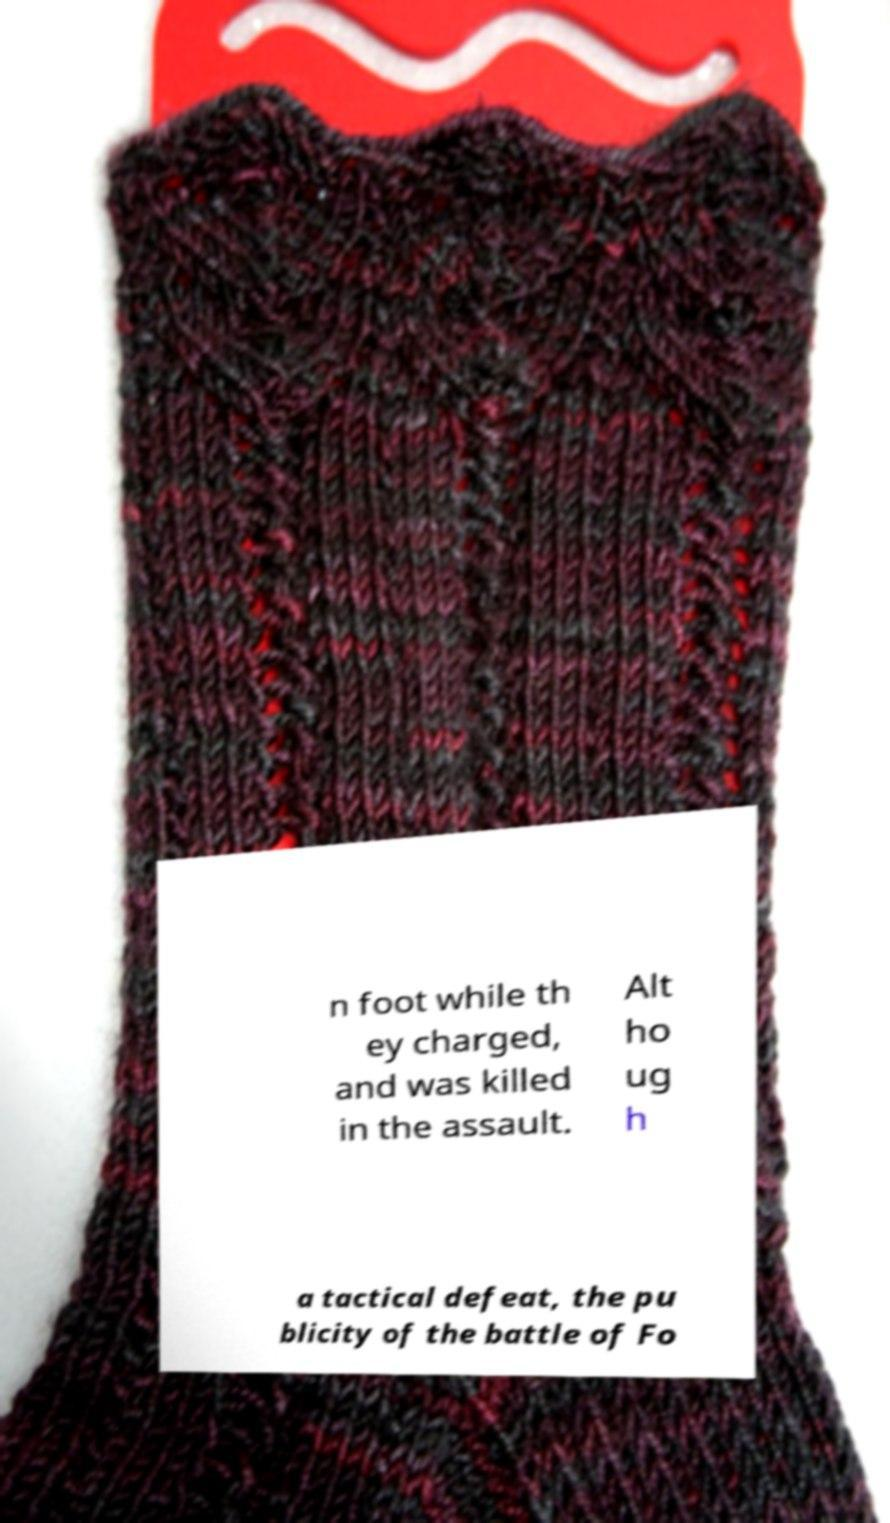Please identify and transcribe the text found in this image. n foot while th ey charged, and was killed in the assault. Alt ho ug h a tactical defeat, the pu blicity of the battle of Fo 